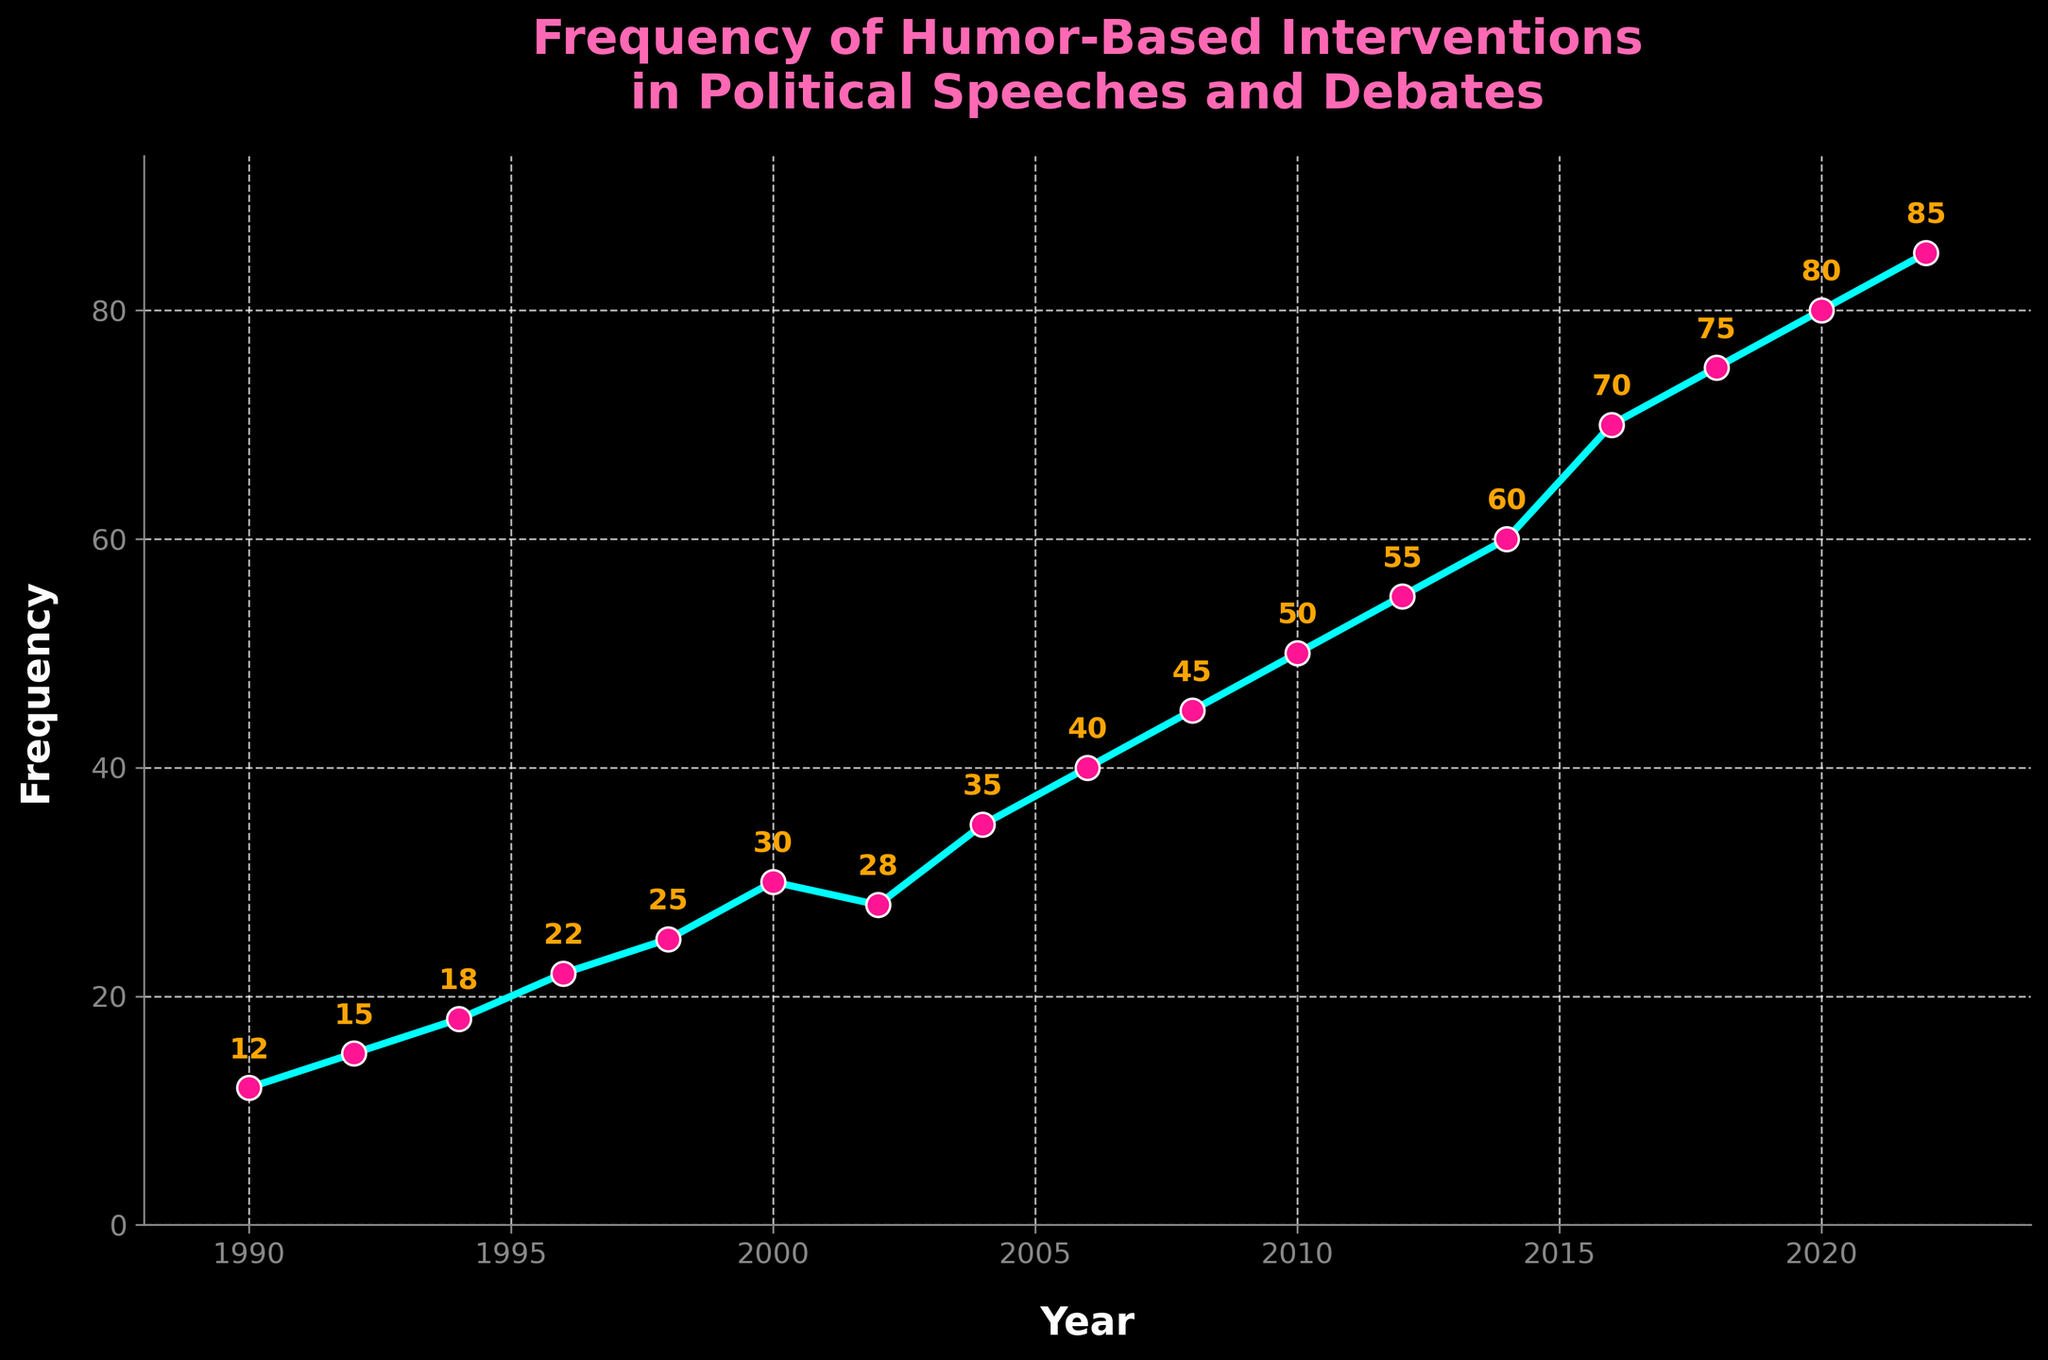Which year saw the highest frequency of humor-based interventions in political speeches and debates? By examining the graph, we identify the peak point on the line plot, which corresponds to the year with the highest frequency value. The highest value is 85, which occurs in the year 2022.
Answer: 2022 Compare the frequency of humor-based interventions in 1998 with that in 2008. Which year had a higher frequency, and by how much? Locate the frequency for both years: 1998 has 25 and 2008 has 45. Subtract the value in 1998 from the value in 2008 (45 - 25 = 20). Hence, 2008 had a higher frequency by 20.
Answer: 2008 by 20 What's the average frequency of humor-based interventions between the years 1990 and 2000 inclusive? Calculate the sum of the frequencies from 1990, 1992, 1994, 1996, 1998, and 2000: (12 + 15 + 18 + 22 + 25 + 30 = 122). There are 6 years, so divide the total by 6 (122 / 6 ≈ 20.33).
Answer: 20.33 What trend can you observe visually in the frequency of humor-based interventions from 1990 to 2022? Observe the overall direction of the line. The frequency increases steadily over the years, indicating an upward trend in the use of humor-based interventions in political speeches and debates.
Answer: Upward trend In which year did the frequency of humor-based interventions first exceed 50? Locate the point where the frequency first goes above 50. The frequency exceeds 50 in the year 2012.
Answer: 2012 What is the difference in frequency between the maximum and minimum values represented on the chart? Identify the maximum value (85 in 2022) and the minimum value (12 in 1990). Calculate the difference (85 - 12 = 73).
Answer: 73 If you took the average frequency for the years 2012, 2014, and 2016, what value would you get? Sum the frequencies for the years 2012, 2014, and 2016 (55 + 60 + 70 = 185). There are 3 years, so divide the total by 3 (185 / 3 ≈ 61.67).
Answer: 61.67 Which year between 2000 and 2020 had the lowest frequency increase compared to its previous value? Calculate the differences year by year: 2002-2000 (28-30=-2), 2004-2002 (35-28=7), 2006-2004 (40-35=5), 2008-2006 (45-40=5), 2010-2008 (50-45=5), 2012-2010 (55-50=5), 2014-2012 (60-55=5), 2016-2014 (70-60=10), 2018-2016 (75-70=5), 2020-2018 (80-75=5). The year 2002 had the lowest frequency increase compared to 2000, which is -2.
Answer: 2002 